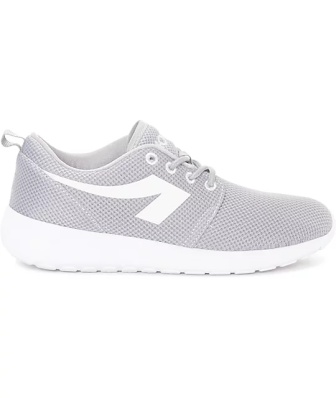What kind of activities do you think this sneaker is best suited for? Considering the sneaker's lightweight design and breathable upper mesh, it's best suited for casual walking or light athletic activities. Its cushioned sole would provide comfortable support for day-to-day wear, such as running errands or social outings. However, the sneaker may not be ideal for intense sports or rugged terrain, where more specialized footwear would be necessary for adequate support and protection. 